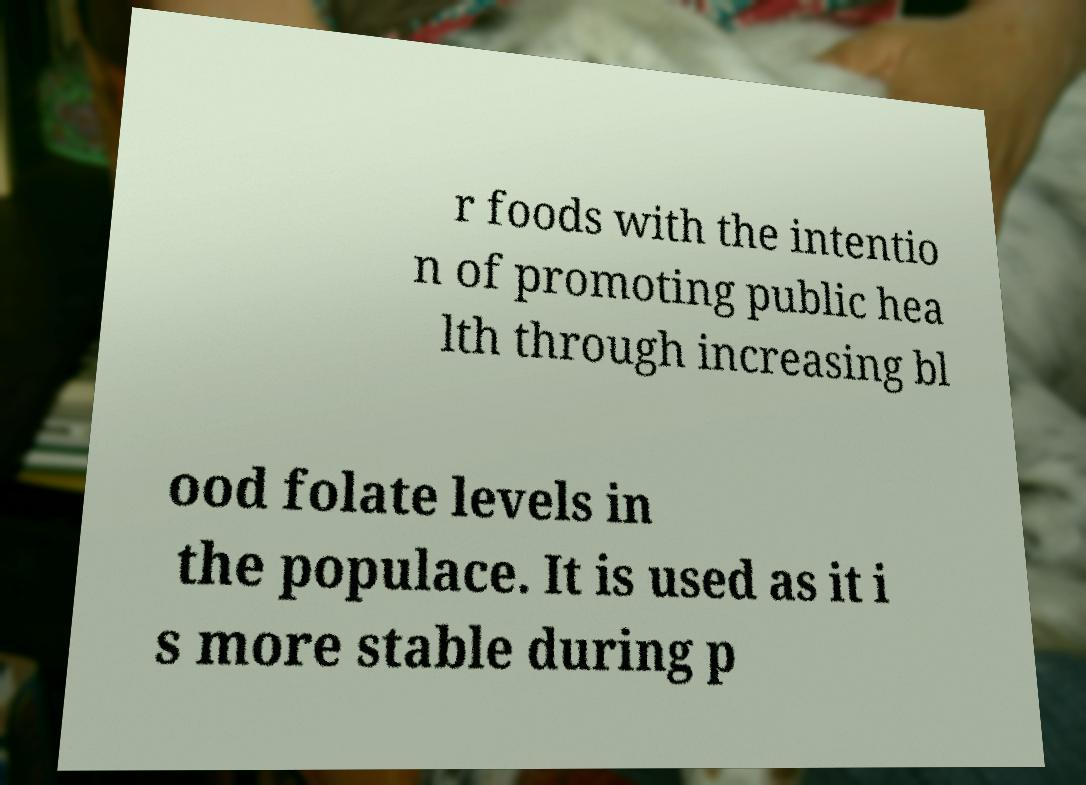Could you assist in decoding the text presented in this image and type it out clearly? r foods with the intentio n of promoting public hea lth through increasing bl ood folate levels in the populace. It is used as it i s more stable during p 